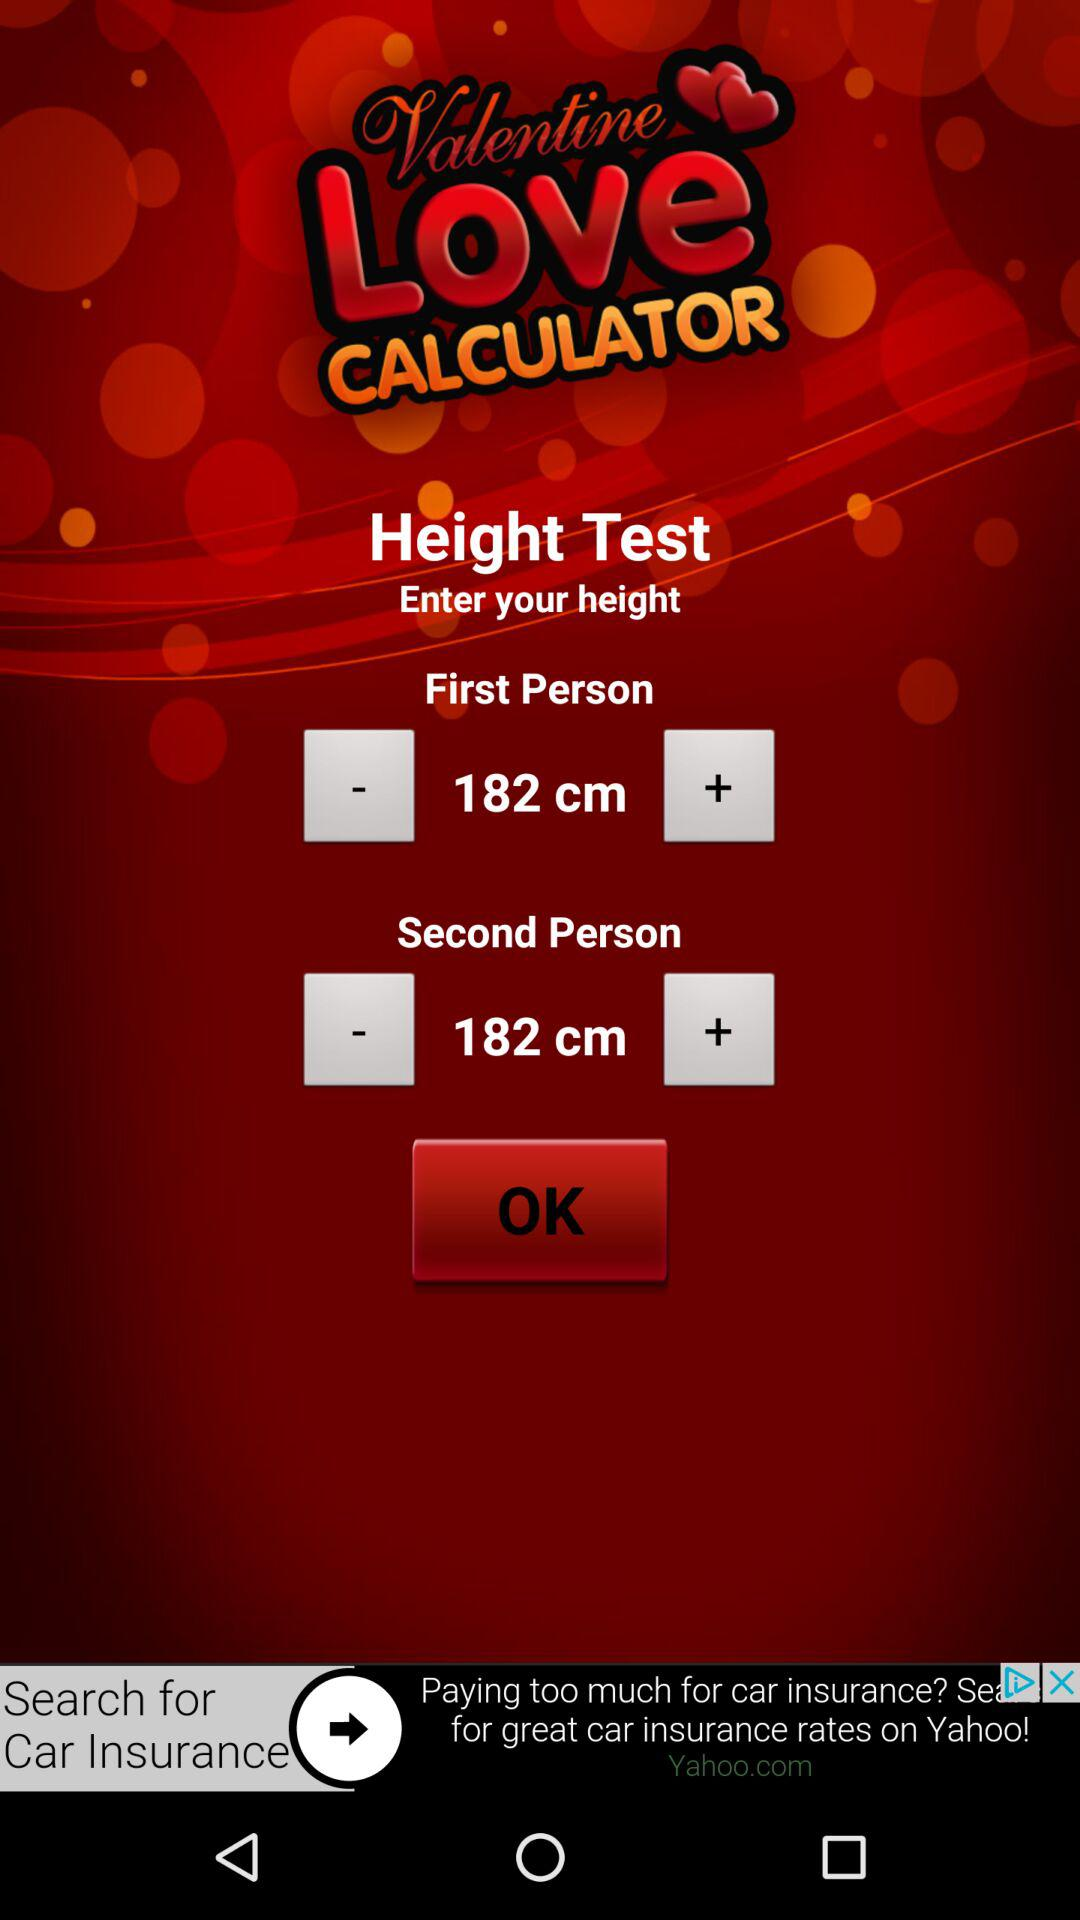How much taller is the first person than the second person?
Answer the question using a single word or phrase. 0 